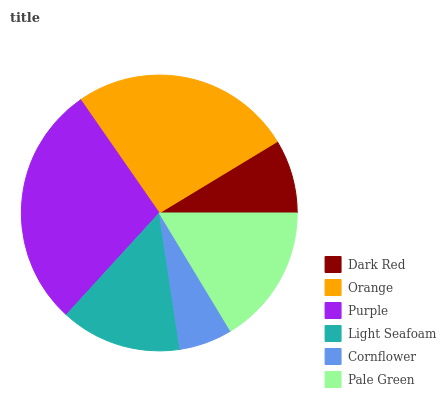Is Cornflower the minimum?
Answer yes or no. Yes. Is Purple the maximum?
Answer yes or no. Yes. Is Orange the minimum?
Answer yes or no. No. Is Orange the maximum?
Answer yes or no. No. Is Orange greater than Dark Red?
Answer yes or no. Yes. Is Dark Red less than Orange?
Answer yes or no. Yes. Is Dark Red greater than Orange?
Answer yes or no. No. Is Orange less than Dark Red?
Answer yes or no. No. Is Pale Green the high median?
Answer yes or no. Yes. Is Light Seafoam the low median?
Answer yes or no. Yes. Is Orange the high median?
Answer yes or no. No. Is Cornflower the low median?
Answer yes or no. No. 